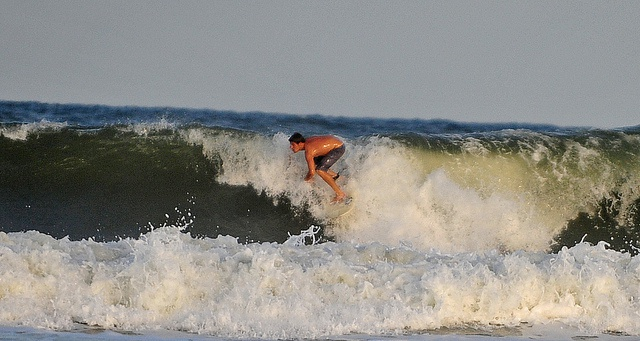Describe the objects in this image and their specific colors. I can see people in gray, brown, black, and maroon tones and surfboard in gray and tan tones in this image. 